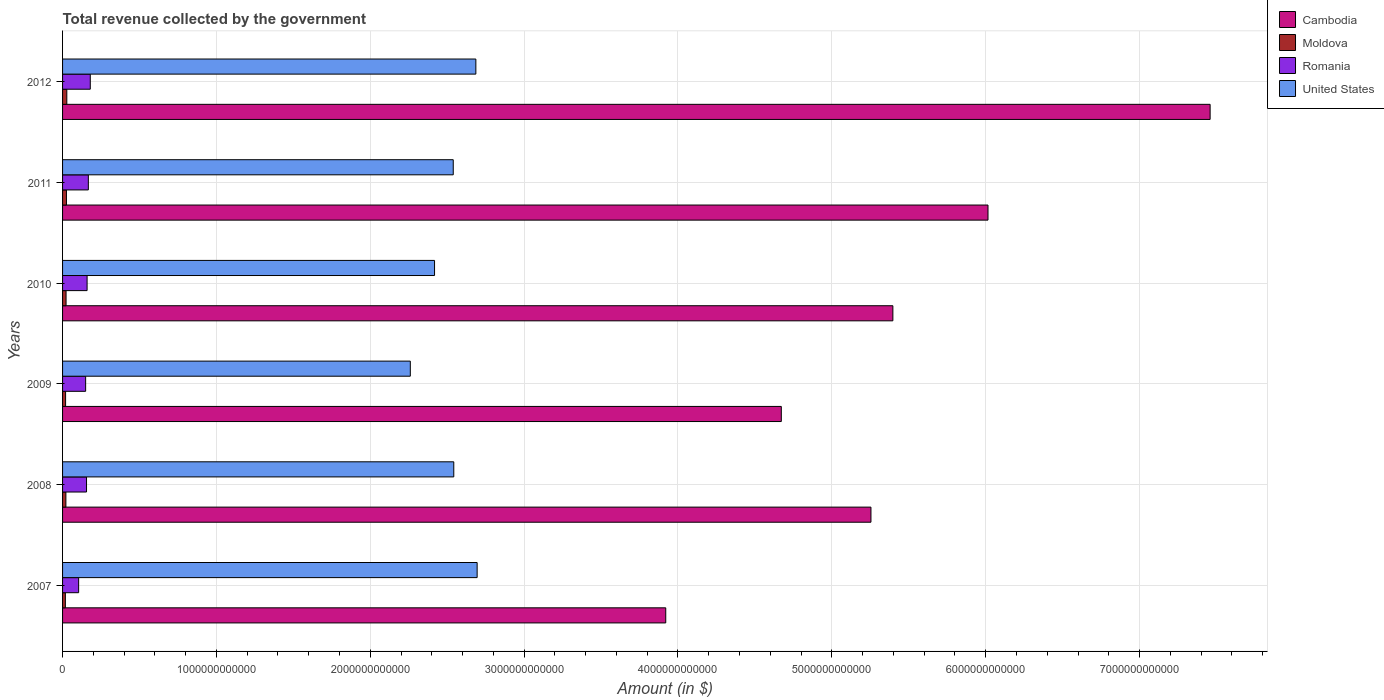How many bars are there on the 3rd tick from the top?
Provide a short and direct response. 4. How many bars are there on the 6th tick from the bottom?
Ensure brevity in your answer.  4. What is the label of the 4th group of bars from the top?
Provide a succinct answer. 2009. What is the total revenue collected by the government in Moldova in 2012?
Your answer should be very brief. 2.76e+1. Across all years, what is the maximum total revenue collected by the government in United States?
Your response must be concise. 2.69e+12. Across all years, what is the minimum total revenue collected by the government in Moldova?
Provide a succinct answer. 1.83e+1. What is the total total revenue collected by the government in Romania in the graph?
Give a very brief answer. 9.17e+11. What is the difference between the total revenue collected by the government in Romania in 2008 and that in 2009?
Offer a very short reply. 5.75e+09. What is the difference between the total revenue collected by the government in Moldova in 2010 and the total revenue collected by the government in United States in 2011?
Keep it short and to the point. -2.52e+12. What is the average total revenue collected by the government in United States per year?
Provide a short and direct response. 2.52e+12. In the year 2009, what is the difference between the total revenue collected by the government in United States and total revenue collected by the government in Moldova?
Your response must be concise. 2.24e+12. In how many years, is the total revenue collected by the government in United States greater than 3400000000000 $?
Offer a terse response. 0. What is the ratio of the total revenue collected by the government in Cambodia in 2008 to that in 2010?
Your response must be concise. 0.97. Is the total revenue collected by the government in Moldova in 2007 less than that in 2011?
Your answer should be very brief. Yes. What is the difference between the highest and the second highest total revenue collected by the government in Romania?
Ensure brevity in your answer.  1.27e+1. What is the difference between the highest and the lowest total revenue collected by the government in Moldova?
Give a very brief answer. 9.26e+09. Is it the case that in every year, the sum of the total revenue collected by the government in United States and total revenue collected by the government in Romania is greater than the sum of total revenue collected by the government in Cambodia and total revenue collected by the government in Moldova?
Ensure brevity in your answer.  Yes. What does the 3rd bar from the top in 2011 represents?
Provide a short and direct response. Moldova. What does the 1st bar from the bottom in 2007 represents?
Provide a short and direct response. Cambodia. Is it the case that in every year, the sum of the total revenue collected by the government in Romania and total revenue collected by the government in Cambodia is greater than the total revenue collected by the government in United States?
Your answer should be very brief. Yes. Are all the bars in the graph horizontal?
Provide a succinct answer. Yes. How many years are there in the graph?
Provide a short and direct response. 6. What is the difference between two consecutive major ticks on the X-axis?
Your response must be concise. 1.00e+12. Are the values on the major ticks of X-axis written in scientific E-notation?
Give a very brief answer. No. Does the graph contain any zero values?
Offer a terse response. No. Does the graph contain grids?
Your response must be concise. Yes. How are the legend labels stacked?
Your answer should be very brief. Vertical. What is the title of the graph?
Ensure brevity in your answer.  Total revenue collected by the government. What is the label or title of the X-axis?
Your response must be concise. Amount (in $). What is the label or title of the Y-axis?
Provide a short and direct response. Years. What is the Amount (in $) of Cambodia in 2007?
Your answer should be compact. 3.92e+12. What is the Amount (in $) in Moldova in 2007?
Provide a succinct answer. 1.83e+1. What is the Amount (in $) of Romania in 2007?
Your response must be concise. 1.04e+11. What is the Amount (in $) in United States in 2007?
Your answer should be very brief. 2.69e+12. What is the Amount (in $) in Cambodia in 2008?
Offer a terse response. 5.25e+12. What is the Amount (in $) of Moldova in 2008?
Keep it short and to the point. 2.16e+1. What is the Amount (in $) in Romania in 2008?
Offer a very short reply. 1.56e+11. What is the Amount (in $) of United States in 2008?
Give a very brief answer. 2.54e+12. What is the Amount (in $) of Cambodia in 2009?
Make the answer very short. 4.67e+12. What is the Amount (in $) in Moldova in 2009?
Make the answer very short. 1.97e+1. What is the Amount (in $) in Romania in 2009?
Provide a short and direct response. 1.50e+11. What is the Amount (in $) of United States in 2009?
Give a very brief answer. 2.26e+12. What is the Amount (in $) of Cambodia in 2010?
Your answer should be very brief. 5.40e+12. What is the Amount (in $) in Moldova in 2010?
Offer a very short reply. 2.27e+1. What is the Amount (in $) in Romania in 2010?
Provide a succinct answer. 1.59e+11. What is the Amount (in $) in United States in 2010?
Keep it short and to the point. 2.42e+12. What is the Amount (in $) of Cambodia in 2011?
Make the answer very short. 6.02e+12. What is the Amount (in $) in Moldova in 2011?
Offer a terse response. 2.53e+1. What is the Amount (in $) in Romania in 2011?
Provide a succinct answer. 1.68e+11. What is the Amount (in $) in United States in 2011?
Your answer should be compact. 2.54e+12. What is the Amount (in $) of Cambodia in 2012?
Your answer should be compact. 7.46e+12. What is the Amount (in $) of Moldova in 2012?
Your answer should be very brief. 2.76e+1. What is the Amount (in $) in Romania in 2012?
Keep it short and to the point. 1.80e+11. What is the Amount (in $) of United States in 2012?
Keep it short and to the point. 2.69e+12. Across all years, what is the maximum Amount (in $) of Cambodia?
Give a very brief answer. 7.46e+12. Across all years, what is the maximum Amount (in $) in Moldova?
Provide a short and direct response. 2.76e+1. Across all years, what is the maximum Amount (in $) in Romania?
Your response must be concise. 1.80e+11. Across all years, what is the maximum Amount (in $) of United States?
Give a very brief answer. 2.69e+12. Across all years, what is the minimum Amount (in $) in Cambodia?
Give a very brief answer. 3.92e+12. Across all years, what is the minimum Amount (in $) in Moldova?
Give a very brief answer. 1.83e+1. Across all years, what is the minimum Amount (in $) of Romania?
Provide a short and direct response. 1.04e+11. Across all years, what is the minimum Amount (in $) of United States?
Keep it short and to the point. 2.26e+12. What is the total Amount (in $) in Cambodia in the graph?
Offer a very short reply. 3.27e+13. What is the total Amount (in $) in Moldova in the graph?
Your response must be concise. 1.35e+11. What is the total Amount (in $) in Romania in the graph?
Your answer should be compact. 9.17e+11. What is the total Amount (in $) of United States in the graph?
Provide a short and direct response. 1.51e+13. What is the difference between the Amount (in $) of Cambodia in 2007 and that in 2008?
Your response must be concise. -1.33e+12. What is the difference between the Amount (in $) of Moldova in 2007 and that in 2008?
Your response must be concise. -3.32e+09. What is the difference between the Amount (in $) in Romania in 2007 and that in 2008?
Provide a succinct answer. -5.13e+1. What is the difference between the Amount (in $) of United States in 2007 and that in 2008?
Offer a terse response. 1.52e+11. What is the difference between the Amount (in $) in Cambodia in 2007 and that in 2009?
Make the answer very short. -7.51e+11. What is the difference between the Amount (in $) of Moldova in 2007 and that in 2009?
Offer a very short reply. -1.41e+09. What is the difference between the Amount (in $) of Romania in 2007 and that in 2009?
Your answer should be compact. -4.55e+1. What is the difference between the Amount (in $) of United States in 2007 and that in 2009?
Give a very brief answer. 4.34e+11. What is the difference between the Amount (in $) in Cambodia in 2007 and that in 2010?
Your answer should be compact. -1.48e+12. What is the difference between the Amount (in $) of Moldova in 2007 and that in 2010?
Keep it short and to the point. -4.42e+09. What is the difference between the Amount (in $) of Romania in 2007 and that in 2010?
Your answer should be very brief. -5.49e+1. What is the difference between the Amount (in $) of United States in 2007 and that in 2010?
Give a very brief answer. 2.77e+11. What is the difference between the Amount (in $) in Cambodia in 2007 and that in 2011?
Your answer should be compact. -2.09e+12. What is the difference between the Amount (in $) in Moldova in 2007 and that in 2011?
Provide a short and direct response. -6.99e+09. What is the difference between the Amount (in $) in Romania in 2007 and that in 2011?
Your answer should be compact. -6.30e+1. What is the difference between the Amount (in $) of United States in 2007 and that in 2011?
Your response must be concise. 1.55e+11. What is the difference between the Amount (in $) of Cambodia in 2007 and that in 2012?
Offer a terse response. -3.54e+12. What is the difference between the Amount (in $) of Moldova in 2007 and that in 2012?
Offer a very short reply. -9.26e+09. What is the difference between the Amount (in $) of Romania in 2007 and that in 2012?
Your response must be concise. -7.57e+1. What is the difference between the Amount (in $) of United States in 2007 and that in 2012?
Provide a succinct answer. 8.30e+09. What is the difference between the Amount (in $) in Cambodia in 2008 and that in 2009?
Your response must be concise. 5.83e+11. What is the difference between the Amount (in $) in Moldova in 2008 and that in 2009?
Ensure brevity in your answer.  1.91e+09. What is the difference between the Amount (in $) in Romania in 2008 and that in 2009?
Your response must be concise. 5.75e+09. What is the difference between the Amount (in $) of United States in 2008 and that in 2009?
Your answer should be very brief. 2.83e+11. What is the difference between the Amount (in $) of Cambodia in 2008 and that in 2010?
Your response must be concise. -1.42e+11. What is the difference between the Amount (in $) in Moldova in 2008 and that in 2010?
Your answer should be compact. -1.10e+09. What is the difference between the Amount (in $) in Romania in 2008 and that in 2010?
Offer a terse response. -3.63e+09. What is the difference between the Amount (in $) in United States in 2008 and that in 2010?
Your response must be concise. 1.25e+11. What is the difference between the Amount (in $) of Cambodia in 2008 and that in 2011?
Provide a succinct answer. -7.61e+11. What is the difference between the Amount (in $) in Moldova in 2008 and that in 2011?
Offer a very short reply. -3.67e+09. What is the difference between the Amount (in $) of Romania in 2008 and that in 2011?
Your response must be concise. -1.17e+1. What is the difference between the Amount (in $) in United States in 2008 and that in 2011?
Provide a short and direct response. 3.50e+09. What is the difference between the Amount (in $) in Cambodia in 2008 and that in 2012?
Ensure brevity in your answer.  -2.20e+12. What is the difference between the Amount (in $) in Moldova in 2008 and that in 2012?
Your response must be concise. -5.94e+09. What is the difference between the Amount (in $) of Romania in 2008 and that in 2012?
Ensure brevity in your answer.  -2.44e+1. What is the difference between the Amount (in $) of United States in 2008 and that in 2012?
Your response must be concise. -1.44e+11. What is the difference between the Amount (in $) of Cambodia in 2009 and that in 2010?
Provide a succinct answer. -7.25e+11. What is the difference between the Amount (in $) in Moldova in 2009 and that in 2010?
Offer a very short reply. -3.01e+09. What is the difference between the Amount (in $) in Romania in 2009 and that in 2010?
Give a very brief answer. -9.39e+09. What is the difference between the Amount (in $) in United States in 2009 and that in 2010?
Offer a terse response. -1.58e+11. What is the difference between the Amount (in $) in Cambodia in 2009 and that in 2011?
Provide a succinct answer. -1.34e+12. What is the difference between the Amount (in $) in Moldova in 2009 and that in 2011?
Provide a succinct answer. -5.58e+09. What is the difference between the Amount (in $) of Romania in 2009 and that in 2011?
Your response must be concise. -1.75e+1. What is the difference between the Amount (in $) in United States in 2009 and that in 2011?
Your answer should be very brief. -2.79e+11. What is the difference between the Amount (in $) in Cambodia in 2009 and that in 2012?
Give a very brief answer. -2.79e+12. What is the difference between the Amount (in $) of Moldova in 2009 and that in 2012?
Your answer should be compact. -7.85e+09. What is the difference between the Amount (in $) of Romania in 2009 and that in 2012?
Provide a short and direct response. -3.02e+1. What is the difference between the Amount (in $) in United States in 2009 and that in 2012?
Give a very brief answer. -4.26e+11. What is the difference between the Amount (in $) of Cambodia in 2010 and that in 2011?
Provide a short and direct response. -6.18e+11. What is the difference between the Amount (in $) in Moldova in 2010 and that in 2011?
Keep it short and to the point. -2.57e+09. What is the difference between the Amount (in $) of Romania in 2010 and that in 2011?
Keep it short and to the point. -8.11e+09. What is the difference between the Amount (in $) in United States in 2010 and that in 2011?
Provide a short and direct response. -1.22e+11. What is the difference between the Amount (in $) of Cambodia in 2010 and that in 2012?
Provide a succinct answer. -2.06e+12. What is the difference between the Amount (in $) of Moldova in 2010 and that in 2012?
Ensure brevity in your answer.  -4.84e+09. What is the difference between the Amount (in $) in Romania in 2010 and that in 2012?
Keep it short and to the point. -2.08e+1. What is the difference between the Amount (in $) in United States in 2010 and that in 2012?
Provide a succinct answer. -2.69e+11. What is the difference between the Amount (in $) of Cambodia in 2011 and that in 2012?
Your response must be concise. -1.44e+12. What is the difference between the Amount (in $) in Moldova in 2011 and that in 2012?
Ensure brevity in your answer.  -2.27e+09. What is the difference between the Amount (in $) of Romania in 2011 and that in 2012?
Provide a short and direct response. -1.27e+1. What is the difference between the Amount (in $) of United States in 2011 and that in 2012?
Give a very brief answer. -1.47e+11. What is the difference between the Amount (in $) of Cambodia in 2007 and the Amount (in $) of Moldova in 2008?
Give a very brief answer. 3.90e+12. What is the difference between the Amount (in $) of Cambodia in 2007 and the Amount (in $) of Romania in 2008?
Keep it short and to the point. 3.76e+12. What is the difference between the Amount (in $) of Cambodia in 2007 and the Amount (in $) of United States in 2008?
Make the answer very short. 1.38e+12. What is the difference between the Amount (in $) in Moldova in 2007 and the Amount (in $) in Romania in 2008?
Ensure brevity in your answer.  -1.37e+11. What is the difference between the Amount (in $) of Moldova in 2007 and the Amount (in $) of United States in 2008?
Offer a terse response. -2.52e+12. What is the difference between the Amount (in $) of Romania in 2007 and the Amount (in $) of United States in 2008?
Make the answer very short. -2.44e+12. What is the difference between the Amount (in $) in Cambodia in 2007 and the Amount (in $) in Moldova in 2009?
Give a very brief answer. 3.90e+12. What is the difference between the Amount (in $) of Cambodia in 2007 and the Amount (in $) of Romania in 2009?
Your answer should be very brief. 3.77e+12. What is the difference between the Amount (in $) of Cambodia in 2007 and the Amount (in $) of United States in 2009?
Your answer should be very brief. 1.66e+12. What is the difference between the Amount (in $) of Moldova in 2007 and the Amount (in $) of Romania in 2009?
Your answer should be compact. -1.32e+11. What is the difference between the Amount (in $) of Moldova in 2007 and the Amount (in $) of United States in 2009?
Offer a terse response. -2.24e+12. What is the difference between the Amount (in $) of Romania in 2007 and the Amount (in $) of United States in 2009?
Your answer should be compact. -2.16e+12. What is the difference between the Amount (in $) of Cambodia in 2007 and the Amount (in $) of Moldova in 2010?
Ensure brevity in your answer.  3.90e+12. What is the difference between the Amount (in $) of Cambodia in 2007 and the Amount (in $) of Romania in 2010?
Offer a terse response. 3.76e+12. What is the difference between the Amount (in $) of Cambodia in 2007 and the Amount (in $) of United States in 2010?
Provide a succinct answer. 1.50e+12. What is the difference between the Amount (in $) of Moldova in 2007 and the Amount (in $) of Romania in 2010?
Provide a succinct answer. -1.41e+11. What is the difference between the Amount (in $) of Moldova in 2007 and the Amount (in $) of United States in 2010?
Provide a short and direct response. -2.40e+12. What is the difference between the Amount (in $) of Romania in 2007 and the Amount (in $) of United States in 2010?
Provide a short and direct response. -2.31e+12. What is the difference between the Amount (in $) in Cambodia in 2007 and the Amount (in $) in Moldova in 2011?
Offer a terse response. 3.90e+12. What is the difference between the Amount (in $) in Cambodia in 2007 and the Amount (in $) in Romania in 2011?
Your answer should be very brief. 3.75e+12. What is the difference between the Amount (in $) of Cambodia in 2007 and the Amount (in $) of United States in 2011?
Your answer should be compact. 1.38e+12. What is the difference between the Amount (in $) of Moldova in 2007 and the Amount (in $) of Romania in 2011?
Offer a very short reply. -1.49e+11. What is the difference between the Amount (in $) of Moldova in 2007 and the Amount (in $) of United States in 2011?
Make the answer very short. -2.52e+12. What is the difference between the Amount (in $) in Romania in 2007 and the Amount (in $) in United States in 2011?
Keep it short and to the point. -2.43e+12. What is the difference between the Amount (in $) in Cambodia in 2007 and the Amount (in $) in Moldova in 2012?
Make the answer very short. 3.89e+12. What is the difference between the Amount (in $) of Cambodia in 2007 and the Amount (in $) of Romania in 2012?
Your response must be concise. 3.74e+12. What is the difference between the Amount (in $) of Cambodia in 2007 and the Amount (in $) of United States in 2012?
Give a very brief answer. 1.23e+12. What is the difference between the Amount (in $) of Moldova in 2007 and the Amount (in $) of Romania in 2012?
Make the answer very short. -1.62e+11. What is the difference between the Amount (in $) of Moldova in 2007 and the Amount (in $) of United States in 2012?
Your answer should be compact. -2.67e+12. What is the difference between the Amount (in $) in Romania in 2007 and the Amount (in $) in United States in 2012?
Make the answer very short. -2.58e+12. What is the difference between the Amount (in $) of Cambodia in 2008 and the Amount (in $) of Moldova in 2009?
Make the answer very short. 5.23e+12. What is the difference between the Amount (in $) of Cambodia in 2008 and the Amount (in $) of Romania in 2009?
Make the answer very short. 5.10e+12. What is the difference between the Amount (in $) of Cambodia in 2008 and the Amount (in $) of United States in 2009?
Your answer should be compact. 2.99e+12. What is the difference between the Amount (in $) in Moldova in 2008 and the Amount (in $) in Romania in 2009?
Provide a succinct answer. -1.28e+11. What is the difference between the Amount (in $) of Moldova in 2008 and the Amount (in $) of United States in 2009?
Your response must be concise. -2.24e+12. What is the difference between the Amount (in $) in Romania in 2008 and the Amount (in $) in United States in 2009?
Your answer should be very brief. -2.10e+12. What is the difference between the Amount (in $) in Cambodia in 2008 and the Amount (in $) in Moldova in 2010?
Give a very brief answer. 5.23e+12. What is the difference between the Amount (in $) in Cambodia in 2008 and the Amount (in $) in Romania in 2010?
Offer a very short reply. 5.09e+12. What is the difference between the Amount (in $) of Cambodia in 2008 and the Amount (in $) of United States in 2010?
Ensure brevity in your answer.  2.84e+12. What is the difference between the Amount (in $) of Moldova in 2008 and the Amount (in $) of Romania in 2010?
Make the answer very short. -1.38e+11. What is the difference between the Amount (in $) of Moldova in 2008 and the Amount (in $) of United States in 2010?
Offer a very short reply. -2.40e+12. What is the difference between the Amount (in $) in Romania in 2008 and the Amount (in $) in United States in 2010?
Give a very brief answer. -2.26e+12. What is the difference between the Amount (in $) of Cambodia in 2008 and the Amount (in $) of Moldova in 2011?
Keep it short and to the point. 5.23e+12. What is the difference between the Amount (in $) in Cambodia in 2008 and the Amount (in $) in Romania in 2011?
Offer a terse response. 5.09e+12. What is the difference between the Amount (in $) of Cambodia in 2008 and the Amount (in $) of United States in 2011?
Give a very brief answer. 2.71e+12. What is the difference between the Amount (in $) of Moldova in 2008 and the Amount (in $) of Romania in 2011?
Make the answer very short. -1.46e+11. What is the difference between the Amount (in $) of Moldova in 2008 and the Amount (in $) of United States in 2011?
Your answer should be very brief. -2.52e+12. What is the difference between the Amount (in $) in Romania in 2008 and the Amount (in $) in United States in 2011?
Ensure brevity in your answer.  -2.38e+12. What is the difference between the Amount (in $) in Cambodia in 2008 and the Amount (in $) in Moldova in 2012?
Your response must be concise. 5.23e+12. What is the difference between the Amount (in $) of Cambodia in 2008 and the Amount (in $) of Romania in 2012?
Offer a very short reply. 5.07e+12. What is the difference between the Amount (in $) of Cambodia in 2008 and the Amount (in $) of United States in 2012?
Your response must be concise. 2.57e+12. What is the difference between the Amount (in $) in Moldova in 2008 and the Amount (in $) in Romania in 2012?
Provide a short and direct response. -1.59e+11. What is the difference between the Amount (in $) in Moldova in 2008 and the Amount (in $) in United States in 2012?
Your answer should be very brief. -2.66e+12. What is the difference between the Amount (in $) in Romania in 2008 and the Amount (in $) in United States in 2012?
Ensure brevity in your answer.  -2.53e+12. What is the difference between the Amount (in $) in Cambodia in 2009 and the Amount (in $) in Moldova in 2010?
Provide a short and direct response. 4.65e+12. What is the difference between the Amount (in $) of Cambodia in 2009 and the Amount (in $) of Romania in 2010?
Provide a short and direct response. 4.51e+12. What is the difference between the Amount (in $) in Cambodia in 2009 and the Amount (in $) in United States in 2010?
Your answer should be very brief. 2.25e+12. What is the difference between the Amount (in $) in Moldova in 2009 and the Amount (in $) in Romania in 2010?
Your answer should be very brief. -1.40e+11. What is the difference between the Amount (in $) of Moldova in 2009 and the Amount (in $) of United States in 2010?
Provide a short and direct response. -2.40e+12. What is the difference between the Amount (in $) in Romania in 2009 and the Amount (in $) in United States in 2010?
Give a very brief answer. -2.27e+12. What is the difference between the Amount (in $) in Cambodia in 2009 and the Amount (in $) in Moldova in 2011?
Keep it short and to the point. 4.65e+12. What is the difference between the Amount (in $) of Cambodia in 2009 and the Amount (in $) of Romania in 2011?
Offer a terse response. 4.50e+12. What is the difference between the Amount (in $) of Cambodia in 2009 and the Amount (in $) of United States in 2011?
Offer a very short reply. 2.13e+12. What is the difference between the Amount (in $) in Moldova in 2009 and the Amount (in $) in Romania in 2011?
Provide a short and direct response. -1.48e+11. What is the difference between the Amount (in $) of Moldova in 2009 and the Amount (in $) of United States in 2011?
Your response must be concise. -2.52e+12. What is the difference between the Amount (in $) of Romania in 2009 and the Amount (in $) of United States in 2011?
Your response must be concise. -2.39e+12. What is the difference between the Amount (in $) of Cambodia in 2009 and the Amount (in $) of Moldova in 2012?
Keep it short and to the point. 4.64e+12. What is the difference between the Amount (in $) of Cambodia in 2009 and the Amount (in $) of Romania in 2012?
Make the answer very short. 4.49e+12. What is the difference between the Amount (in $) of Cambodia in 2009 and the Amount (in $) of United States in 2012?
Your answer should be very brief. 1.99e+12. What is the difference between the Amount (in $) of Moldova in 2009 and the Amount (in $) of Romania in 2012?
Offer a very short reply. -1.60e+11. What is the difference between the Amount (in $) in Moldova in 2009 and the Amount (in $) in United States in 2012?
Make the answer very short. -2.67e+12. What is the difference between the Amount (in $) of Romania in 2009 and the Amount (in $) of United States in 2012?
Ensure brevity in your answer.  -2.54e+12. What is the difference between the Amount (in $) in Cambodia in 2010 and the Amount (in $) in Moldova in 2011?
Your answer should be very brief. 5.37e+12. What is the difference between the Amount (in $) of Cambodia in 2010 and the Amount (in $) of Romania in 2011?
Ensure brevity in your answer.  5.23e+12. What is the difference between the Amount (in $) in Cambodia in 2010 and the Amount (in $) in United States in 2011?
Make the answer very short. 2.86e+12. What is the difference between the Amount (in $) of Moldova in 2010 and the Amount (in $) of Romania in 2011?
Your answer should be very brief. -1.45e+11. What is the difference between the Amount (in $) of Moldova in 2010 and the Amount (in $) of United States in 2011?
Offer a very short reply. -2.52e+12. What is the difference between the Amount (in $) in Romania in 2010 and the Amount (in $) in United States in 2011?
Provide a succinct answer. -2.38e+12. What is the difference between the Amount (in $) of Cambodia in 2010 and the Amount (in $) of Moldova in 2012?
Keep it short and to the point. 5.37e+12. What is the difference between the Amount (in $) of Cambodia in 2010 and the Amount (in $) of Romania in 2012?
Offer a terse response. 5.22e+12. What is the difference between the Amount (in $) of Cambodia in 2010 and the Amount (in $) of United States in 2012?
Your answer should be very brief. 2.71e+12. What is the difference between the Amount (in $) of Moldova in 2010 and the Amount (in $) of Romania in 2012?
Keep it short and to the point. -1.57e+11. What is the difference between the Amount (in $) of Moldova in 2010 and the Amount (in $) of United States in 2012?
Your response must be concise. -2.66e+12. What is the difference between the Amount (in $) of Romania in 2010 and the Amount (in $) of United States in 2012?
Provide a succinct answer. -2.53e+12. What is the difference between the Amount (in $) of Cambodia in 2011 and the Amount (in $) of Moldova in 2012?
Make the answer very short. 5.99e+12. What is the difference between the Amount (in $) of Cambodia in 2011 and the Amount (in $) of Romania in 2012?
Offer a terse response. 5.83e+12. What is the difference between the Amount (in $) of Cambodia in 2011 and the Amount (in $) of United States in 2012?
Make the answer very short. 3.33e+12. What is the difference between the Amount (in $) in Moldova in 2011 and the Amount (in $) in Romania in 2012?
Your answer should be very brief. -1.55e+11. What is the difference between the Amount (in $) in Moldova in 2011 and the Amount (in $) in United States in 2012?
Provide a succinct answer. -2.66e+12. What is the difference between the Amount (in $) of Romania in 2011 and the Amount (in $) of United States in 2012?
Offer a terse response. -2.52e+12. What is the average Amount (in $) of Cambodia per year?
Your answer should be compact. 5.45e+12. What is the average Amount (in $) of Moldova per year?
Your answer should be very brief. 2.25e+1. What is the average Amount (in $) in Romania per year?
Provide a succinct answer. 1.53e+11. What is the average Amount (in $) in United States per year?
Your response must be concise. 2.52e+12. In the year 2007, what is the difference between the Amount (in $) in Cambodia and Amount (in $) in Moldova?
Offer a very short reply. 3.90e+12. In the year 2007, what is the difference between the Amount (in $) of Cambodia and Amount (in $) of Romania?
Provide a succinct answer. 3.82e+12. In the year 2007, what is the difference between the Amount (in $) in Cambodia and Amount (in $) in United States?
Give a very brief answer. 1.23e+12. In the year 2007, what is the difference between the Amount (in $) in Moldova and Amount (in $) in Romania?
Your answer should be very brief. -8.62e+1. In the year 2007, what is the difference between the Amount (in $) of Moldova and Amount (in $) of United States?
Provide a short and direct response. -2.68e+12. In the year 2007, what is the difference between the Amount (in $) in Romania and Amount (in $) in United States?
Make the answer very short. -2.59e+12. In the year 2008, what is the difference between the Amount (in $) of Cambodia and Amount (in $) of Moldova?
Your answer should be very brief. 5.23e+12. In the year 2008, what is the difference between the Amount (in $) of Cambodia and Amount (in $) of Romania?
Your answer should be very brief. 5.10e+12. In the year 2008, what is the difference between the Amount (in $) of Cambodia and Amount (in $) of United States?
Your answer should be compact. 2.71e+12. In the year 2008, what is the difference between the Amount (in $) in Moldova and Amount (in $) in Romania?
Offer a terse response. -1.34e+11. In the year 2008, what is the difference between the Amount (in $) of Moldova and Amount (in $) of United States?
Give a very brief answer. -2.52e+12. In the year 2008, what is the difference between the Amount (in $) in Romania and Amount (in $) in United States?
Make the answer very short. -2.39e+12. In the year 2009, what is the difference between the Amount (in $) in Cambodia and Amount (in $) in Moldova?
Offer a very short reply. 4.65e+12. In the year 2009, what is the difference between the Amount (in $) of Cambodia and Amount (in $) of Romania?
Your answer should be very brief. 4.52e+12. In the year 2009, what is the difference between the Amount (in $) of Cambodia and Amount (in $) of United States?
Offer a terse response. 2.41e+12. In the year 2009, what is the difference between the Amount (in $) of Moldova and Amount (in $) of Romania?
Your response must be concise. -1.30e+11. In the year 2009, what is the difference between the Amount (in $) of Moldova and Amount (in $) of United States?
Give a very brief answer. -2.24e+12. In the year 2009, what is the difference between the Amount (in $) of Romania and Amount (in $) of United States?
Give a very brief answer. -2.11e+12. In the year 2010, what is the difference between the Amount (in $) of Cambodia and Amount (in $) of Moldova?
Provide a short and direct response. 5.37e+12. In the year 2010, what is the difference between the Amount (in $) in Cambodia and Amount (in $) in Romania?
Offer a very short reply. 5.24e+12. In the year 2010, what is the difference between the Amount (in $) in Cambodia and Amount (in $) in United States?
Ensure brevity in your answer.  2.98e+12. In the year 2010, what is the difference between the Amount (in $) in Moldova and Amount (in $) in Romania?
Offer a very short reply. -1.37e+11. In the year 2010, what is the difference between the Amount (in $) of Moldova and Amount (in $) of United States?
Offer a very short reply. -2.39e+12. In the year 2010, what is the difference between the Amount (in $) of Romania and Amount (in $) of United States?
Keep it short and to the point. -2.26e+12. In the year 2011, what is the difference between the Amount (in $) in Cambodia and Amount (in $) in Moldova?
Provide a short and direct response. 5.99e+12. In the year 2011, what is the difference between the Amount (in $) of Cambodia and Amount (in $) of Romania?
Provide a succinct answer. 5.85e+12. In the year 2011, what is the difference between the Amount (in $) in Cambodia and Amount (in $) in United States?
Make the answer very short. 3.48e+12. In the year 2011, what is the difference between the Amount (in $) of Moldova and Amount (in $) of Romania?
Offer a terse response. -1.42e+11. In the year 2011, what is the difference between the Amount (in $) in Moldova and Amount (in $) in United States?
Provide a succinct answer. -2.51e+12. In the year 2011, what is the difference between the Amount (in $) in Romania and Amount (in $) in United States?
Provide a succinct answer. -2.37e+12. In the year 2012, what is the difference between the Amount (in $) of Cambodia and Amount (in $) of Moldova?
Keep it short and to the point. 7.43e+12. In the year 2012, what is the difference between the Amount (in $) of Cambodia and Amount (in $) of Romania?
Ensure brevity in your answer.  7.28e+12. In the year 2012, what is the difference between the Amount (in $) of Cambodia and Amount (in $) of United States?
Offer a very short reply. 4.77e+12. In the year 2012, what is the difference between the Amount (in $) of Moldova and Amount (in $) of Romania?
Your response must be concise. -1.53e+11. In the year 2012, what is the difference between the Amount (in $) in Moldova and Amount (in $) in United States?
Provide a succinct answer. -2.66e+12. In the year 2012, what is the difference between the Amount (in $) of Romania and Amount (in $) of United States?
Make the answer very short. -2.51e+12. What is the ratio of the Amount (in $) of Cambodia in 2007 to that in 2008?
Offer a very short reply. 0.75. What is the ratio of the Amount (in $) of Moldova in 2007 to that in 2008?
Make the answer very short. 0.85. What is the ratio of the Amount (in $) in Romania in 2007 to that in 2008?
Provide a succinct answer. 0.67. What is the ratio of the Amount (in $) in United States in 2007 to that in 2008?
Provide a succinct answer. 1.06. What is the ratio of the Amount (in $) in Cambodia in 2007 to that in 2009?
Your answer should be compact. 0.84. What is the ratio of the Amount (in $) of Moldova in 2007 to that in 2009?
Ensure brevity in your answer.  0.93. What is the ratio of the Amount (in $) in Romania in 2007 to that in 2009?
Keep it short and to the point. 0.7. What is the ratio of the Amount (in $) in United States in 2007 to that in 2009?
Provide a short and direct response. 1.19. What is the ratio of the Amount (in $) of Cambodia in 2007 to that in 2010?
Make the answer very short. 0.73. What is the ratio of the Amount (in $) of Moldova in 2007 to that in 2010?
Ensure brevity in your answer.  0.81. What is the ratio of the Amount (in $) in Romania in 2007 to that in 2010?
Make the answer very short. 0.66. What is the ratio of the Amount (in $) of United States in 2007 to that in 2010?
Make the answer very short. 1.11. What is the ratio of the Amount (in $) in Cambodia in 2007 to that in 2011?
Provide a short and direct response. 0.65. What is the ratio of the Amount (in $) in Moldova in 2007 to that in 2011?
Provide a short and direct response. 0.72. What is the ratio of the Amount (in $) in Romania in 2007 to that in 2011?
Your answer should be compact. 0.62. What is the ratio of the Amount (in $) of United States in 2007 to that in 2011?
Keep it short and to the point. 1.06. What is the ratio of the Amount (in $) of Cambodia in 2007 to that in 2012?
Ensure brevity in your answer.  0.53. What is the ratio of the Amount (in $) in Moldova in 2007 to that in 2012?
Your answer should be compact. 0.66. What is the ratio of the Amount (in $) of Romania in 2007 to that in 2012?
Offer a very short reply. 0.58. What is the ratio of the Amount (in $) of United States in 2007 to that in 2012?
Your answer should be compact. 1. What is the ratio of the Amount (in $) of Cambodia in 2008 to that in 2009?
Offer a terse response. 1.12. What is the ratio of the Amount (in $) of Moldova in 2008 to that in 2009?
Offer a very short reply. 1.1. What is the ratio of the Amount (in $) in Romania in 2008 to that in 2009?
Offer a terse response. 1.04. What is the ratio of the Amount (in $) of Cambodia in 2008 to that in 2010?
Provide a succinct answer. 0.97. What is the ratio of the Amount (in $) in Moldova in 2008 to that in 2010?
Ensure brevity in your answer.  0.95. What is the ratio of the Amount (in $) in Romania in 2008 to that in 2010?
Give a very brief answer. 0.98. What is the ratio of the Amount (in $) of United States in 2008 to that in 2010?
Give a very brief answer. 1.05. What is the ratio of the Amount (in $) in Cambodia in 2008 to that in 2011?
Your answer should be very brief. 0.87. What is the ratio of the Amount (in $) of Moldova in 2008 to that in 2011?
Make the answer very short. 0.85. What is the ratio of the Amount (in $) of Romania in 2008 to that in 2011?
Your response must be concise. 0.93. What is the ratio of the Amount (in $) of Cambodia in 2008 to that in 2012?
Your response must be concise. 0.7. What is the ratio of the Amount (in $) in Moldova in 2008 to that in 2012?
Offer a very short reply. 0.78. What is the ratio of the Amount (in $) in Romania in 2008 to that in 2012?
Give a very brief answer. 0.86. What is the ratio of the Amount (in $) in United States in 2008 to that in 2012?
Your response must be concise. 0.95. What is the ratio of the Amount (in $) in Cambodia in 2009 to that in 2010?
Your answer should be compact. 0.87. What is the ratio of the Amount (in $) of Moldova in 2009 to that in 2010?
Your answer should be very brief. 0.87. What is the ratio of the Amount (in $) in Romania in 2009 to that in 2010?
Your answer should be compact. 0.94. What is the ratio of the Amount (in $) in United States in 2009 to that in 2010?
Your response must be concise. 0.93. What is the ratio of the Amount (in $) in Cambodia in 2009 to that in 2011?
Provide a succinct answer. 0.78. What is the ratio of the Amount (in $) in Moldova in 2009 to that in 2011?
Provide a succinct answer. 0.78. What is the ratio of the Amount (in $) in Romania in 2009 to that in 2011?
Your response must be concise. 0.9. What is the ratio of the Amount (in $) in United States in 2009 to that in 2011?
Provide a short and direct response. 0.89. What is the ratio of the Amount (in $) of Cambodia in 2009 to that in 2012?
Offer a terse response. 0.63. What is the ratio of the Amount (in $) of Moldova in 2009 to that in 2012?
Provide a succinct answer. 0.72. What is the ratio of the Amount (in $) in Romania in 2009 to that in 2012?
Provide a succinct answer. 0.83. What is the ratio of the Amount (in $) in United States in 2009 to that in 2012?
Provide a succinct answer. 0.84. What is the ratio of the Amount (in $) in Cambodia in 2010 to that in 2011?
Keep it short and to the point. 0.9. What is the ratio of the Amount (in $) of Moldova in 2010 to that in 2011?
Offer a very short reply. 0.9. What is the ratio of the Amount (in $) of Romania in 2010 to that in 2011?
Give a very brief answer. 0.95. What is the ratio of the Amount (in $) in United States in 2010 to that in 2011?
Offer a terse response. 0.95. What is the ratio of the Amount (in $) of Cambodia in 2010 to that in 2012?
Keep it short and to the point. 0.72. What is the ratio of the Amount (in $) of Moldova in 2010 to that in 2012?
Offer a terse response. 0.82. What is the ratio of the Amount (in $) of Romania in 2010 to that in 2012?
Ensure brevity in your answer.  0.88. What is the ratio of the Amount (in $) in Cambodia in 2011 to that in 2012?
Offer a very short reply. 0.81. What is the ratio of the Amount (in $) in Moldova in 2011 to that in 2012?
Give a very brief answer. 0.92. What is the ratio of the Amount (in $) of Romania in 2011 to that in 2012?
Your response must be concise. 0.93. What is the ratio of the Amount (in $) of United States in 2011 to that in 2012?
Your response must be concise. 0.95. What is the difference between the highest and the second highest Amount (in $) in Cambodia?
Provide a succinct answer. 1.44e+12. What is the difference between the highest and the second highest Amount (in $) of Moldova?
Ensure brevity in your answer.  2.27e+09. What is the difference between the highest and the second highest Amount (in $) in Romania?
Your answer should be very brief. 1.27e+1. What is the difference between the highest and the second highest Amount (in $) of United States?
Your response must be concise. 8.30e+09. What is the difference between the highest and the lowest Amount (in $) in Cambodia?
Provide a short and direct response. 3.54e+12. What is the difference between the highest and the lowest Amount (in $) of Moldova?
Your answer should be very brief. 9.26e+09. What is the difference between the highest and the lowest Amount (in $) in Romania?
Ensure brevity in your answer.  7.57e+1. What is the difference between the highest and the lowest Amount (in $) in United States?
Ensure brevity in your answer.  4.34e+11. 